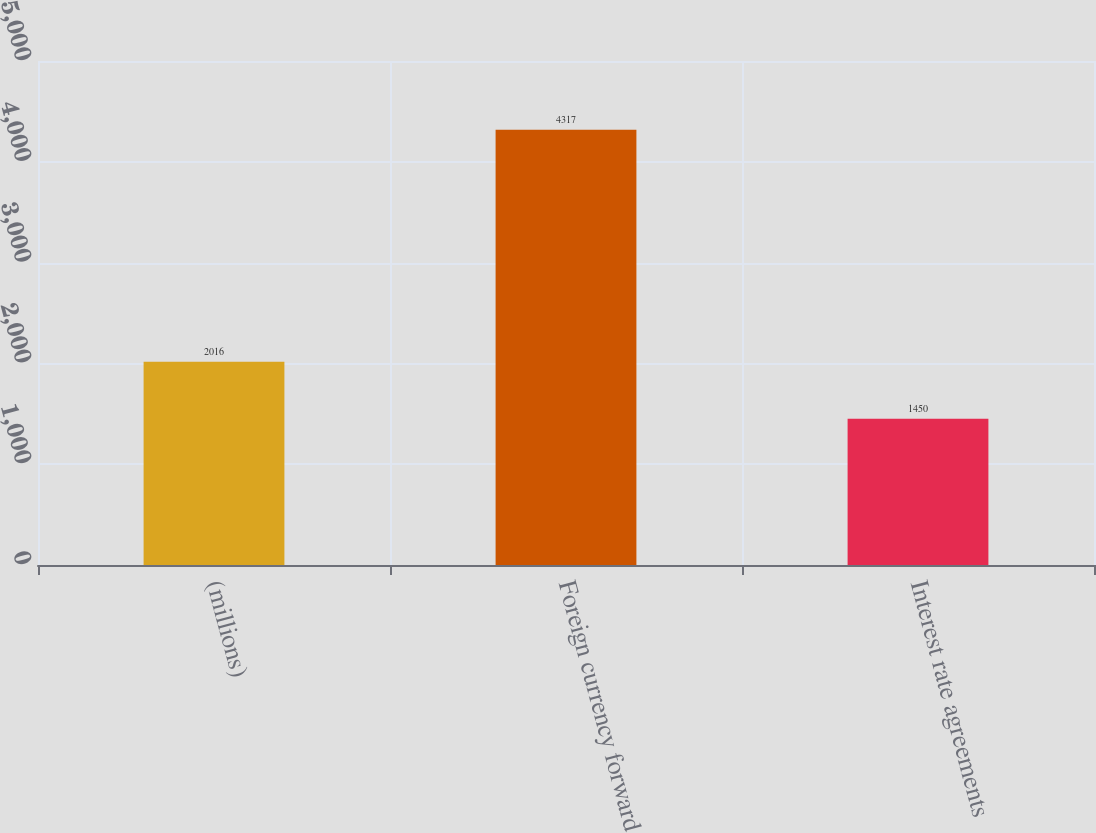<chart> <loc_0><loc_0><loc_500><loc_500><bar_chart><fcel>(millions)<fcel>Foreign currency forward<fcel>Interest rate agreements<nl><fcel>2016<fcel>4317<fcel>1450<nl></chart> 